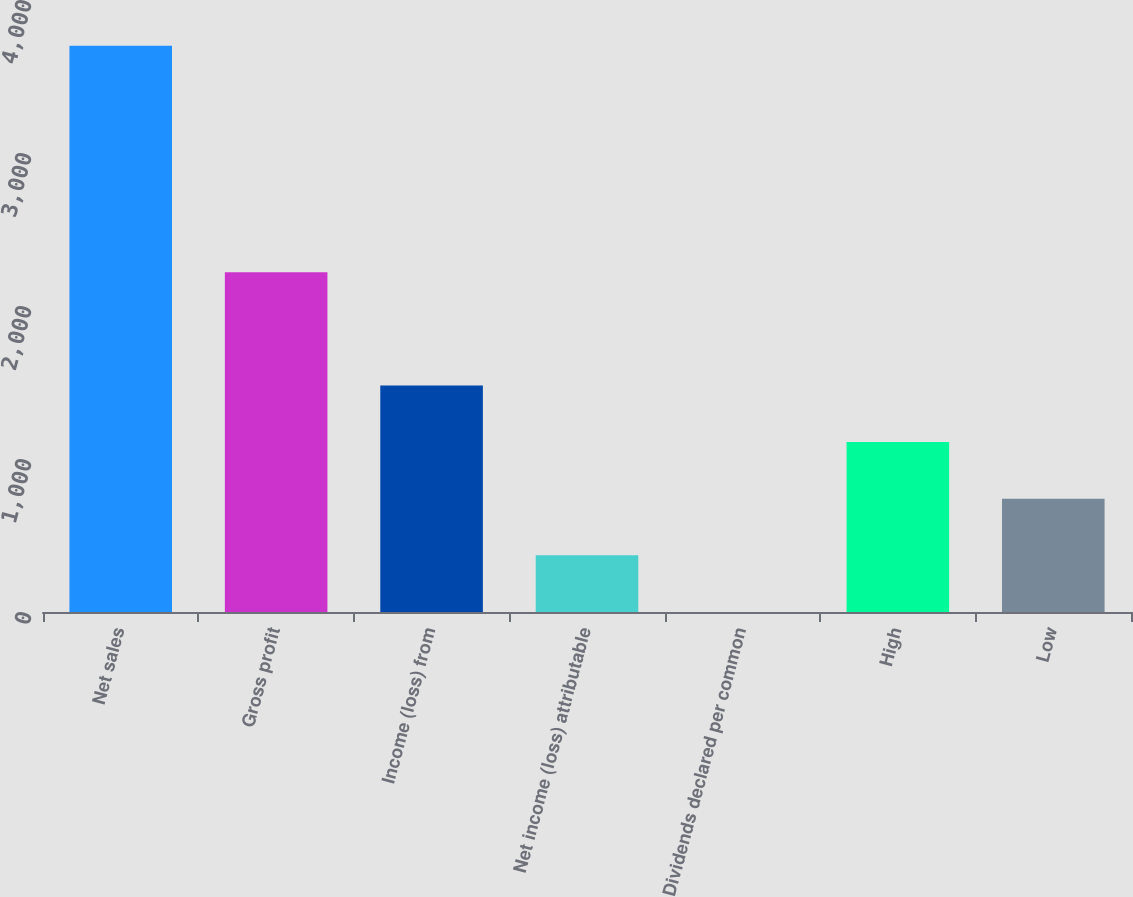<chart> <loc_0><loc_0><loc_500><loc_500><bar_chart><fcel>Net sales<fcel>Gross profit<fcel>Income (loss) from<fcel>Net income (loss) attributable<fcel>Dividends declared per common<fcel>High<fcel>Low<nl><fcel>3701<fcel>2220.69<fcel>1480.55<fcel>370.33<fcel>0.25<fcel>1110.47<fcel>740.4<nl></chart> 